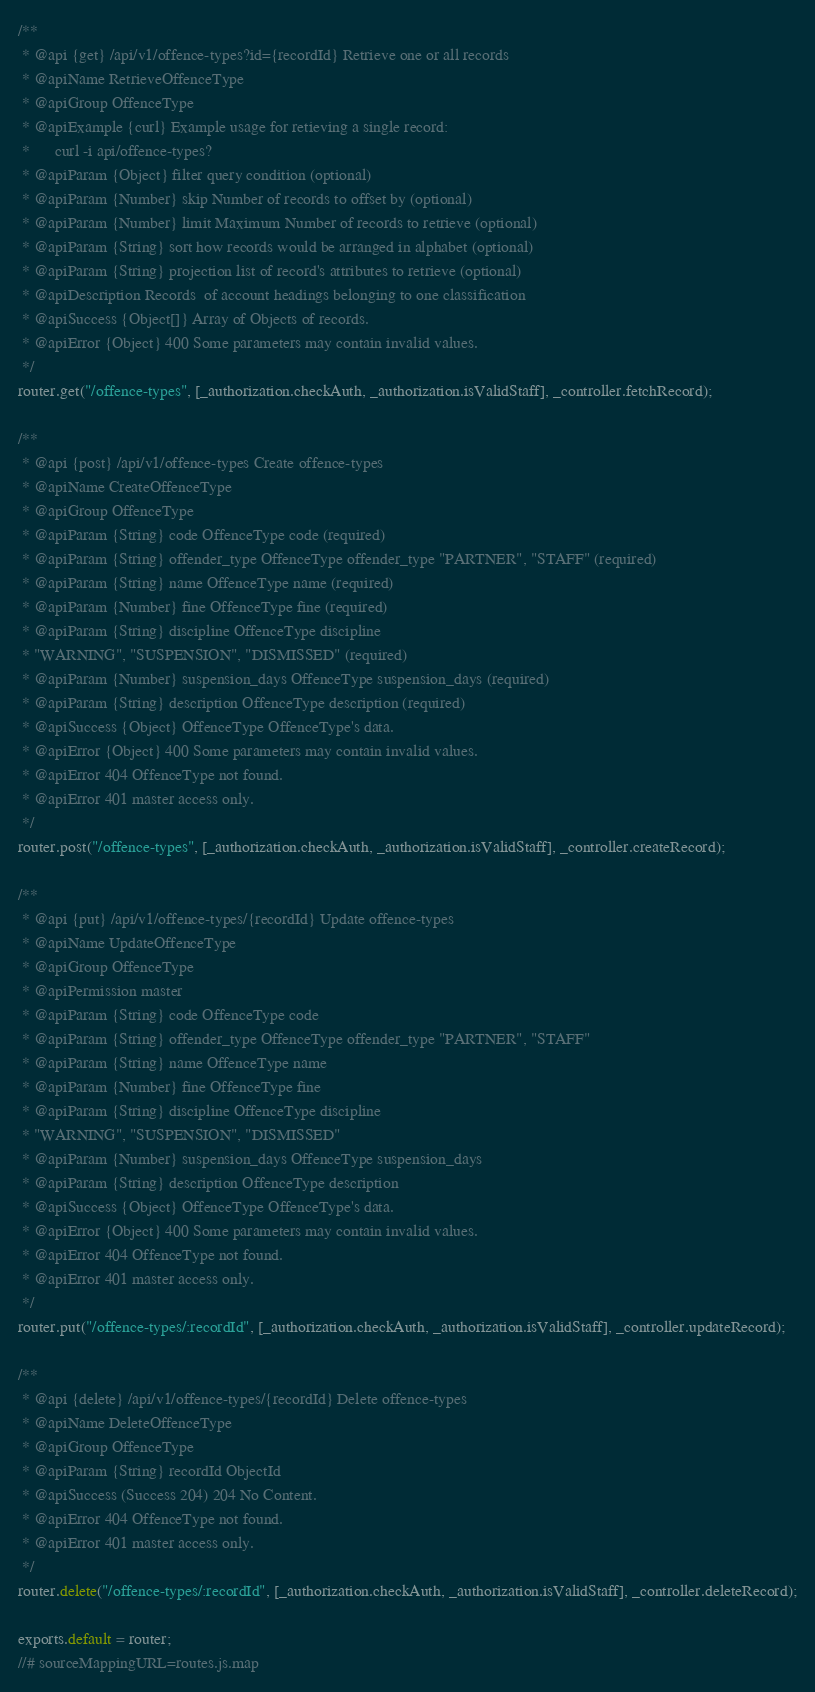Convert code to text. <code><loc_0><loc_0><loc_500><loc_500><_JavaScript_>/**
 * @api {get} /api/v1/offence-types?id={recordId} Retrieve one or all records
 * @apiName RetrieveOffenceType
 * @apiGroup OffenceType
 * @apiExample {curl} Example usage for retieving a single record:
 *      curl -i api/offence-types?
 * @apiParam {Object} filter query condition (optional)
 * @apiParam {Number} skip Number of records to offset by (optional)
 * @apiParam {Number} limit Maximum Number of records to retrieve (optional)
 * @apiParam {String} sort how records would be arranged in alphabet (optional)
 * @apiParam {String} projection list of record's attributes to retrieve (optional)
 * @apiDescription Records  of account headings belonging to one classification
 * @apiSuccess {Object[]} Array of Objects of records.
 * @apiError {Object} 400 Some parameters may contain invalid values.
 */
router.get("/offence-types", [_authorization.checkAuth, _authorization.isValidStaff], _controller.fetchRecord);

/**
 * @api {post} /api/v1/offence-types Create offence-types
 * @apiName CreateOffenceType
 * @apiGroup OffenceType
 * @apiParam {String} code OffenceType code (required)
 * @apiParam {String} offender_type OffenceType offender_type "PARTNER", "STAFF" (required)
 * @apiParam {String} name OffenceType name (required)
 * @apiParam {Number} fine OffenceType fine (required)
 * @apiParam {String} discipline OffenceType discipline
 * "WARNING", "SUSPENSION", "DISMISSED" (required)
 * @apiParam {Number} suspension_days OffenceType suspension_days (required)
 * @apiParam {String} description OffenceType description (required)
 * @apiSuccess {Object} OffenceType OffenceType's data.
 * @apiError {Object} 400 Some parameters may contain invalid values.
 * @apiError 404 OffenceType not found.
 * @apiError 401 master access only.
 */
router.post("/offence-types", [_authorization.checkAuth, _authorization.isValidStaff], _controller.createRecord);

/**
 * @api {put} /api/v1/offence-types/{recordId} Update offence-types
 * @apiName UpdateOffenceType
 * @apiGroup OffenceType
 * @apiPermission master
 * @apiParam {String} code OffenceType code
 * @apiParam {String} offender_type OffenceType offender_type "PARTNER", "STAFF"
 * @apiParam {String} name OffenceType name
 * @apiParam {Number} fine OffenceType fine
 * @apiParam {String} discipline OffenceType discipline
 * "WARNING", "SUSPENSION", "DISMISSED"
 * @apiParam {Number} suspension_days OffenceType suspension_days
 * @apiParam {String} description OffenceType description
 * @apiSuccess {Object} OffenceType OffenceType's data.
 * @apiError {Object} 400 Some parameters may contain invalid values.
 * @apiError 404 OffenceType not found.
 * @apiError 401 master access only.
 */
router.put("/offence-types/:recordId", [_authorization.checkAuth, _authorization.isValidStaff], _controller.updateRecord);

/**
 * @api {delete} /api/v1/offence-types/{recordId} Delete offence-types
 * @apiName DeleteOffenceType
 * @apiGroup OffenceType
 * @apiParam {String} recordId ObjectId
 * @apiSuccess (Success 204) 204 No Content.
 * @apiError 404 OffenceType not found.
 * @apiError 401 master access only.
 */
router.delete("/offence-types/:recordId", [_authorization.checkAuth, _authorization.isValidStaff], _controller.deleteRecord);

exports.default = router;
//# sourceMappingURL=routes.js.map</code> 